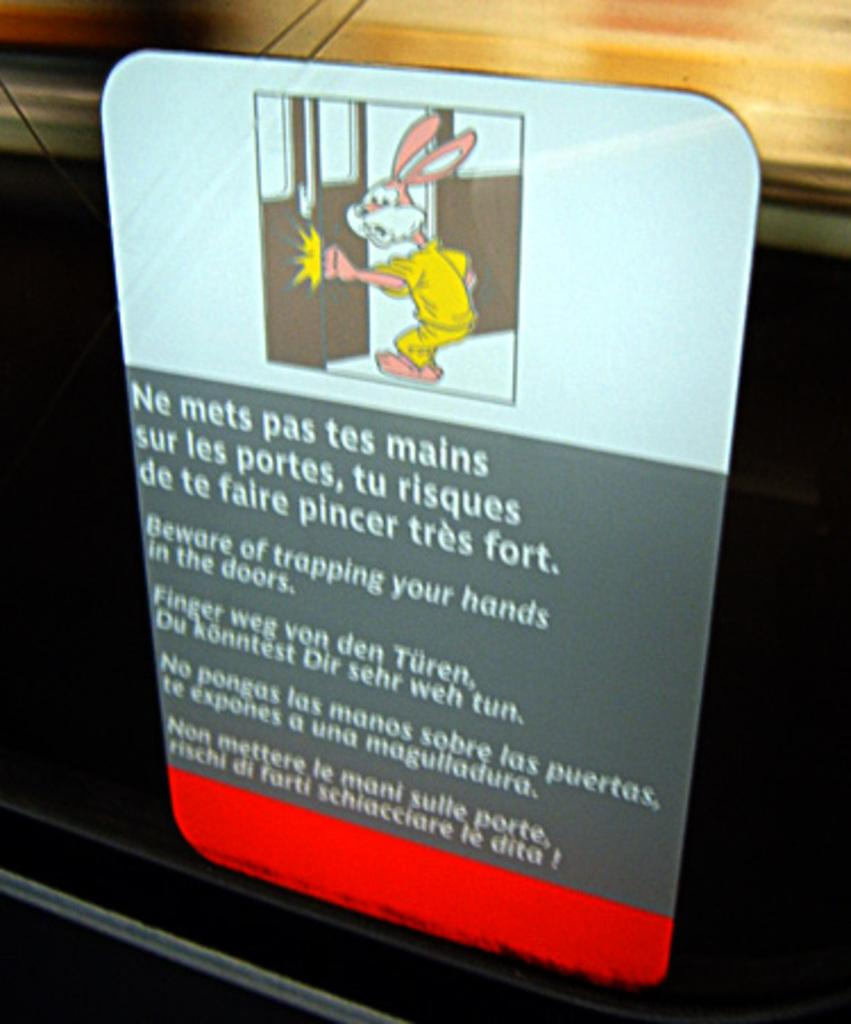What is featured on the board in the image? There is text and a cartoon image of a rabbit on the board in the image. Can you describe the cartoon image on the board? The cartoon image on the board is of a rabbit. What can be observed about the background of the image? The background of the image is blurry. What type of boot is being used to promote health in the image? There is no boot or reference to health promotion in the image; it features text and a cartoon image of a rabbit on a board. How many potatoes are visible in the image? There are no potatoes present in the image. 